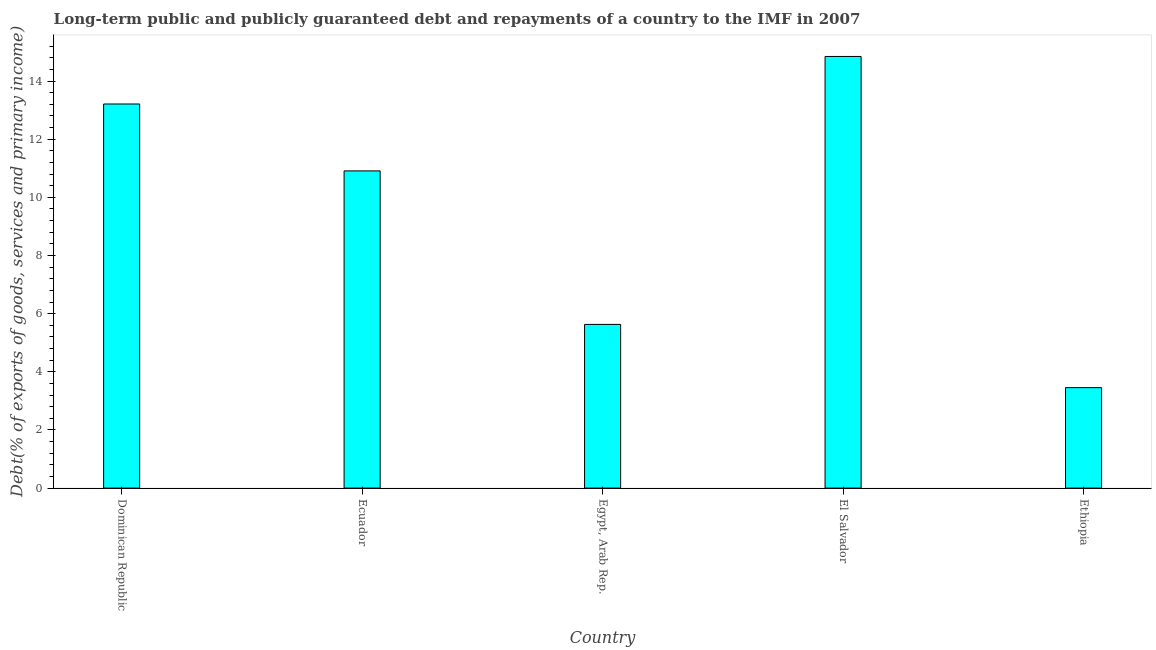What is the title of the graph?
Make the answer very short. Long-term public and publicly guaranteed debt and repayments of a country to the IMF in 2007. What is the label or title of the X-axis?
Your answer should be very brief. Country. What is the label or title of the Y-axis?
Keep it short and to the point. Debt(% of exports of goods, services and primary income). What is the debt service in Ecuador?
Make the answer very short. 10.91. Across all countries, what is the maximum debt service?
Ensure brevity in your answer.  14.85. Across all countries, what is the minimum debt service?
Offer a terse response. 3.46. In which country was the debt service maximum?
Ensure brevity in your answer.  El Salvador. In which country was the debt service minimum?
Provide a short and direct response. Ethiopia. What is the sum of the debt service?
Offer a very short reply. 48.05. What is the difference between the debt service in Dominican Republic and El Salvador?
Keep it short and to the point. -1.64. What is the average debt service per country?
Provide a succinct answer. 9.61. What is the median debt service?
Keep it short and to the point. 10.91. What is the ratio of the debt service in Ecuador to that in Egypt, Arab Rep.?
Ensure brevity in your answer.  1.94. What is the difference between the highest and the second highest debt service?
Offer a very short reply. 1.64. Is the sum of the debt service in Egypt, Arab Rep. and Ethiopia greater than the maximum debt service across all countries?
Your answer should be very brief. No. What is the difference between the highest and the lowest debt service?
Your answer should be compact. 11.39. How many countries are there in the graph?
Provide a short and direct response. 5. Are the values on the major ticks of Y-axis written in scientific E-notation?
Make the answer very short. No. What is the Debt(% of exports of goods, services and primary income) in Dominican Republic?
Make the answer very short. 13.21. What is the Debt(% of exports of goods, services and primary income) in Ecuador?
Your response must be concise. 10.91. What is the Debt(% of exports of goods, services and primary income) in Egypt, Arab Rep.?
Offer a very short reply. 5.63. What is the Debt(% of exports of goods, services and primary income) in El Salvador?
Offer a very short reply. 14.85. What is the Debt(% of exports of goods, services and primary income) in Ethiopia?
Offer a very short reply. 3.46. What is the difference between the Debt(% of exports of goods, services and primary income) in Dominican Republic and Ecuador?
Your answer should be compact. 2.3. What is the difference between the Debt(% of exports of goods, services and primary income) in Dominican Republic and Egypt, Arab Rep.?
Give a very brief answer. 7.58. What is the difference between the Debt(% of exports of goods, services and primary income) in Dominican Republic and El Salvador?
Ensure brevity in your answer.  -1.64. What is the difference between the Debt(% of exports of goods, services and primary income) in Dominican Republic and Ethiopia?
Offer a very short reply. 9.76. What is the difference between the Debt(% of exports of goods, services and primary income) in Ecuador and Egypt, Arab Rep.?
Offer a very short reply. 5.28. What is the difference between the Debt(% of exports of goods, services and primary income) in Ecuador and El Salvador?
Your answer should be compact. -3.94. What is the difference between the Debt(% of exports of goods, services and primary income) in Ecuador and Ethiopia?
Give a very brief answer. 7.45. What is the difference between the Debt(% of exports of goods, services and primary income) in Egypt, Arab Rep. and El Salvador?
Offer a very short reply. -9.22. What is the difference between the Debt(% of exports of goods, services and primary income) in Egypt, Arab Rep. and Ethiopia?
Your answer should be very brief. 2.17. What is the difference between the Debt(% of exports of goods, services and primary income) in El Salvador and Ethiopia?
Ensure brevity in your answer.  11.39. What is the ratio of the Debt(% of exports of goods, services and primary income) in Dominican Republic to that in Ecuador?
Make the answer very short. 1.21. What is the ratio of the Debt(% of exports of goods, services and primary income) in Dominican Republic to that in Egypt, Arab Rep.?
Provide a succinct answer. 2.35. What is the ratio of the Debt(% of exports of goods, services and primary income) in Dominican Republic to that in El Salvador?
Give a very brief answer. 0.89. What is the ratio of the Debt(% of exports of goods, services and primary income) in Dominican Republic to that in Ethiopia?
Give a very brief answer. 3.82. What is the ratio of the Debt(% of exports of goods, services and primary income) in Ecuador to that in Egypt, Arab Rep.?
Ensure brevity in your answer.  1.94. What is the ratio of the Debt(% of exports of goods, services and primary income) in Ecuador to that in El Salvador?
Ensure brevity in your answer.  0.73. What is the ratio of the Debt(% of exports of goods, services and primary income) in Ecuador to that in Ethiopia?
Ensure brevity in your answer.  3.16. What is the ratio of the Debt(% of exports of goods, services and primary income) in Egypt, Arab Rep. to that in El Salvador?
Make the answer very short. 0.38. What is the ratio of the Debt(% of exports of goods, services and primary income) in Egypt, Arab Rep. to that in Ethiopia?
Keep it short and to the point. 1.63. What is the ratio of the Debt(% of exports of goods, services and primary income) in El Salvador to that in Ethiopia?
Provide a succinct answer. 4.3. 